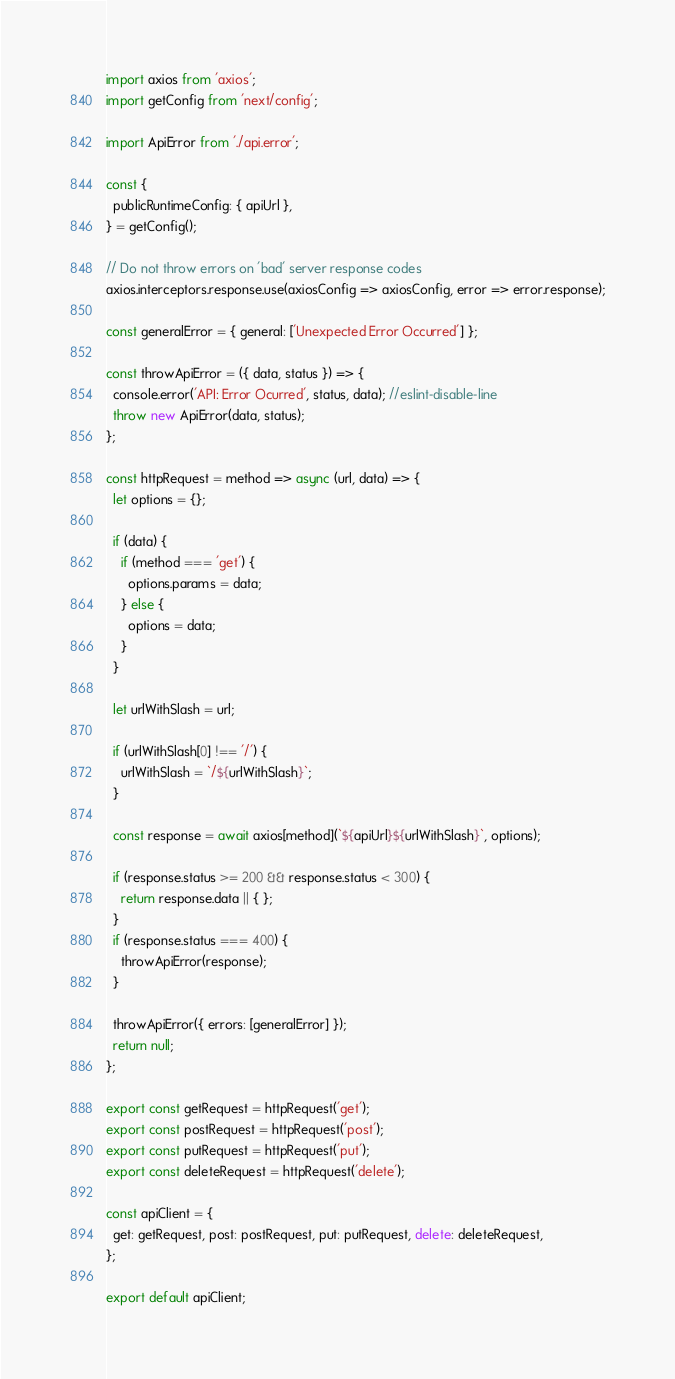Convert code to text. <code><loc_0><loc_0><loc_500><loc_500><_JavaScript_>import axios from 'axios';
import getConfig from 'next/config';

import ApiError from './api.error';

const {
  publicRuntimeConfig: { apiUrl },
} = getConfig();

// Do not throw errors on 'bad' server response codes
axios.interceptors.response.use(axiosConfig => axiosConfig, error => error.response);

const generalError = { general: ['Unexpected Error Occurred'] };

const throwApiError = ({ data, status }) => {
  console.error('API: Error Ocurred', status, data); //eslint-disable-line
  throw new ApiError(data, status);
};

const httpRequest = method => async (url, data) => {
  let options = {};

  if (data) {
    if (method === 'get') {
      options.params = data;
    } else {
      options = data;
    }
  }

  let urlWithSlash = url;

  if (urlWithSlash[0] !== '/') {
    urlWithSlash = `/${urlWithSlash}`;
  }

  const response = await axios[method](`${apiUrl}${urlWithSlash}`, options);

  if (response.status >= 200 && response.status < 300) {
    return response.data || { };
  }
  if (response.status === 400) {
    throwApiError(response);
  }

  throwApiError({ errors: [generalError] });
  return null;
};

export const getRequest = httpRequest('get');
export const postRequest = httpRequest('post');
export const putRequest = httpRequest('put');
export const deleteRequest = httpRequest('delete');

const apiClient = {
  get: getRequest, post: postRequest, put: putRequest, delete: deleteRequest,
};

export default apiClient;
</code> 